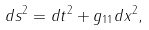Convert formula to latex. <formula><loc_0><loc_0><loc_500><loc_500>d s ^ { 2 } = d t ^ { 2 } + g _ { 1 1 } d x ^ { 2 } ,</formula> 